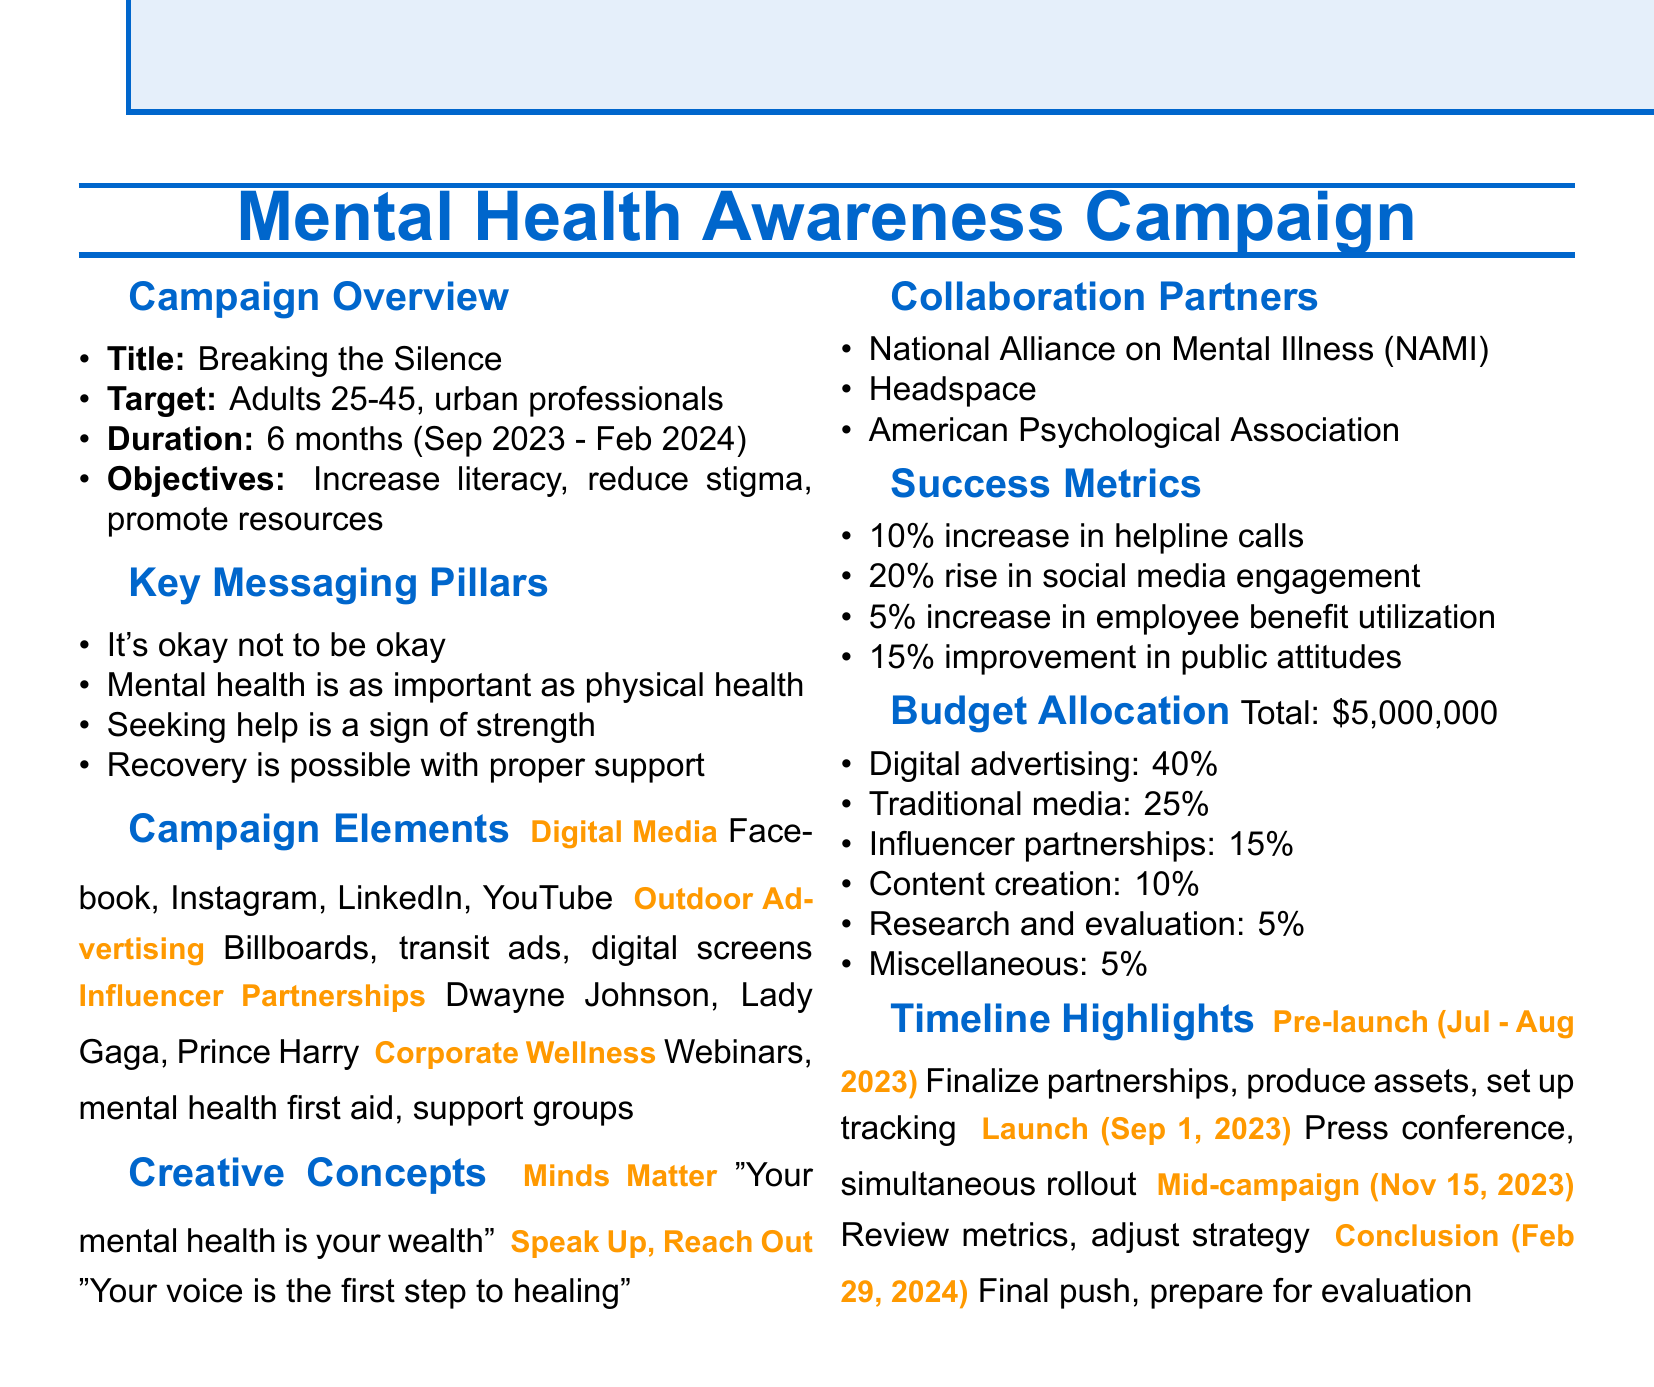What is the campaign title? The title of the campaign is mentioned at the beginning of the document under the campaign overview section.
Answer: Breaking the Silence What is the campaign duration? The duration is specified in the campaign overview section, indicating the start and end dates.
Answer: 6 months (September 2023 - February 2024) Who is the target audience? The target audience is outlined in the campaign overview, detailing the demographic focus of the campaign.
Answer: Adults aged 25-45, urban professionals What are the primary objectives of the campaign? The primary objectives are listed in the campaign overview and highlight the goals of the campaign.
Answer: Increase mental health literacy, Reduce stigma associated with seeking help, Promote available mental health resources How many influencers are listed as partners? The number of influencer partners can be counted in the proposed campaign elements section where they are listed.
Answer: 3 What is the success metric for social media engagement? This information is found in the success metrics section as it quantifies the expected increase in engagement.
Answer: 20% rise in social media engagement on mental health topics What is the total budget for the campaign? The total budget is indicated in the budget allocation section of the document.
Answer: $5,000,000 When does the campaign launch? The launch date is specified in the timeline highlights section, detailing the exact date of the campaign kickoff.
Answer: September 1, 2023 What is the tagline for the "Minds Matter" concept? The tagline is provided along with the creative concept title in the creative concepts section of the document.
Answer: Your mental health is your wealth 